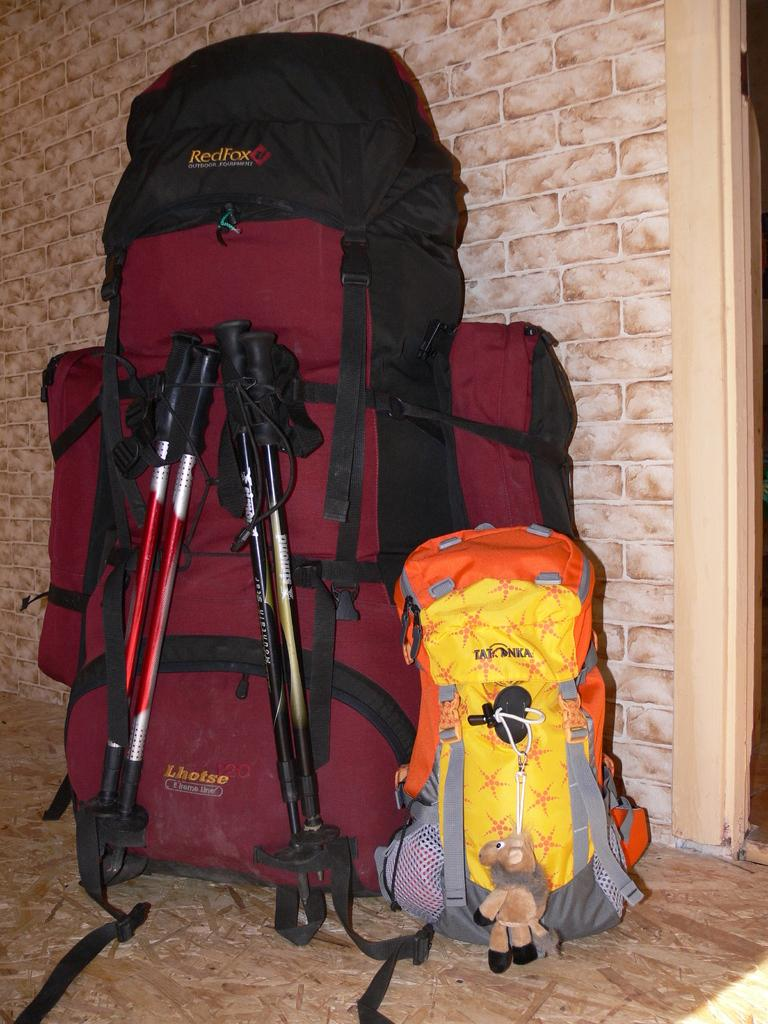How many backpacks are visible in the image? There are two backpacks in the image. Can you describe the size difference between the backpacks? One backpack is bigger than the other. What color is the horse in the image? There is no horse present in the image. How many points does the beam have in the image? There is no beam present in the image. 